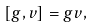<formula> <loc_0><loc_0><loc_500><loc_500>[ g , v ] = g v ,</formula> 